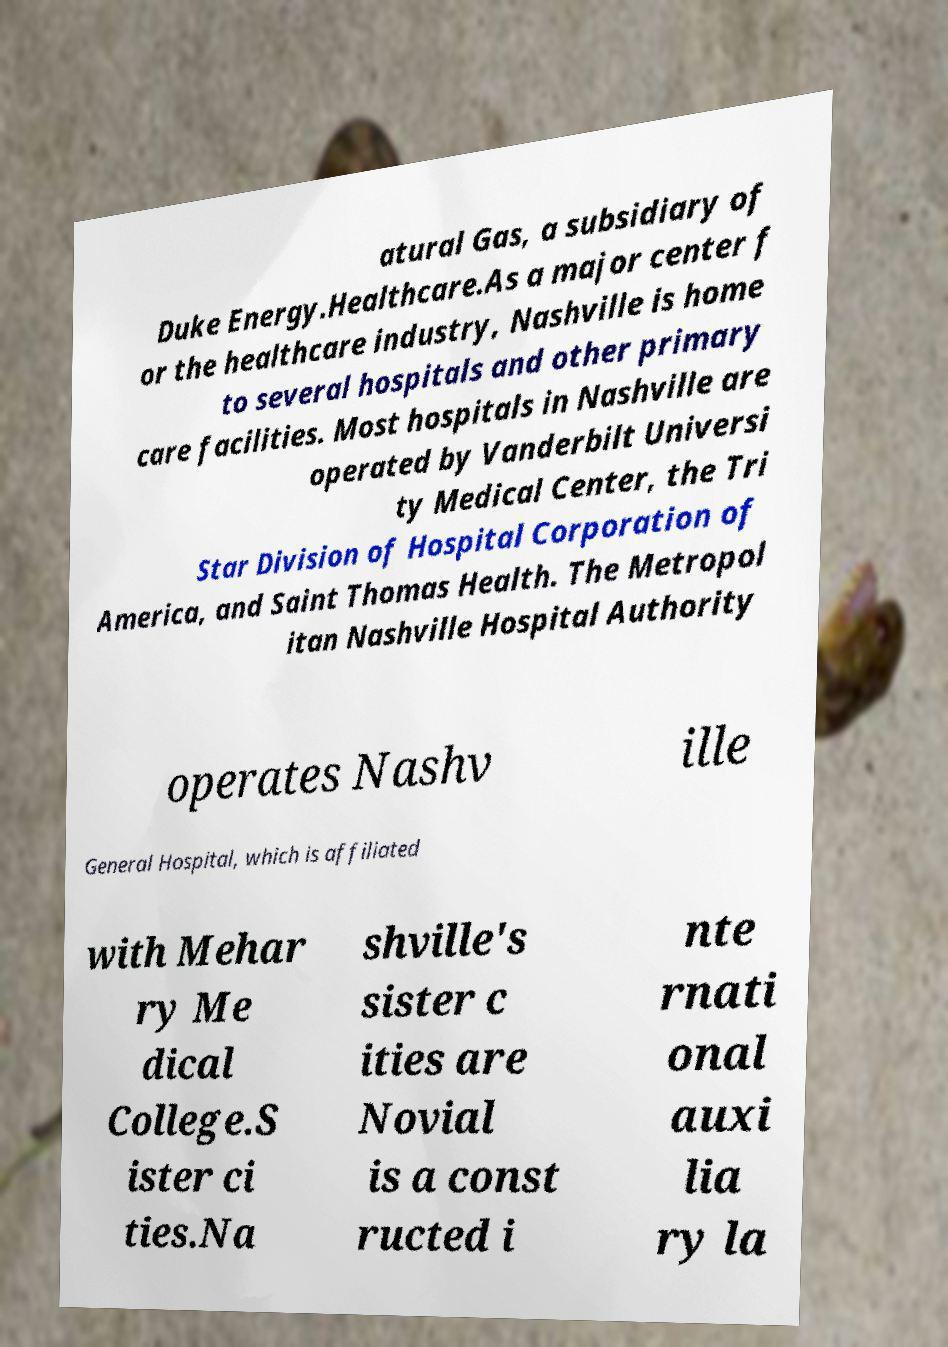What messages or text are displayed in this image? I need them in a readable, typed format. atural Gas, a subsidiary of Duke Energy.Healthcare.As a major center f or the healthcare industry, Nashville is home to several hospitals and other primary care facilities. Most hospitals in Nashville are operated by Vanderbilt Universi ty Medical Center, the Tri Star Division of Hospital Corporation of America, and Saint Thomas Health. The Metropol itan Nashville Hospital Authority operates Nashv ille General Hospital, which is affiliated with Mehar ry Me dical College.S ister ci ties.Na shville's sister c ities are Novial is a const ructed i nte rnati onal auxi lia ry la 